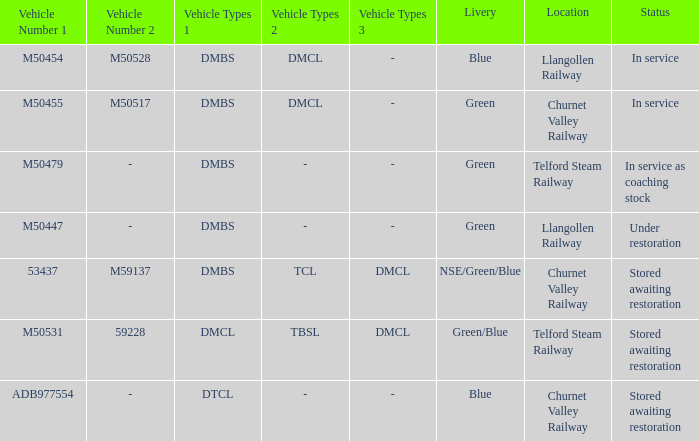What status is the vehicle numbers of adb977554? Stored awaiting restoration. 